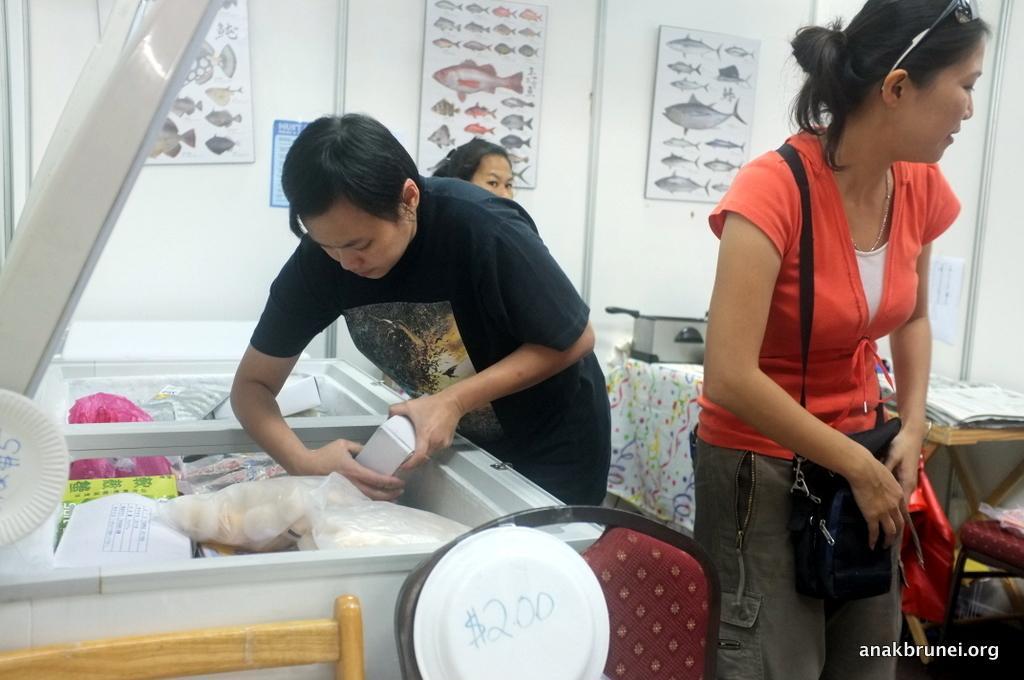Can you describe this image briefly? In this picture there are three persons. The woman is standing and wearing a bag. The man is removing the box from the fridge. There is a table and chair. The wall contain fish chart. There are papers on the table. 